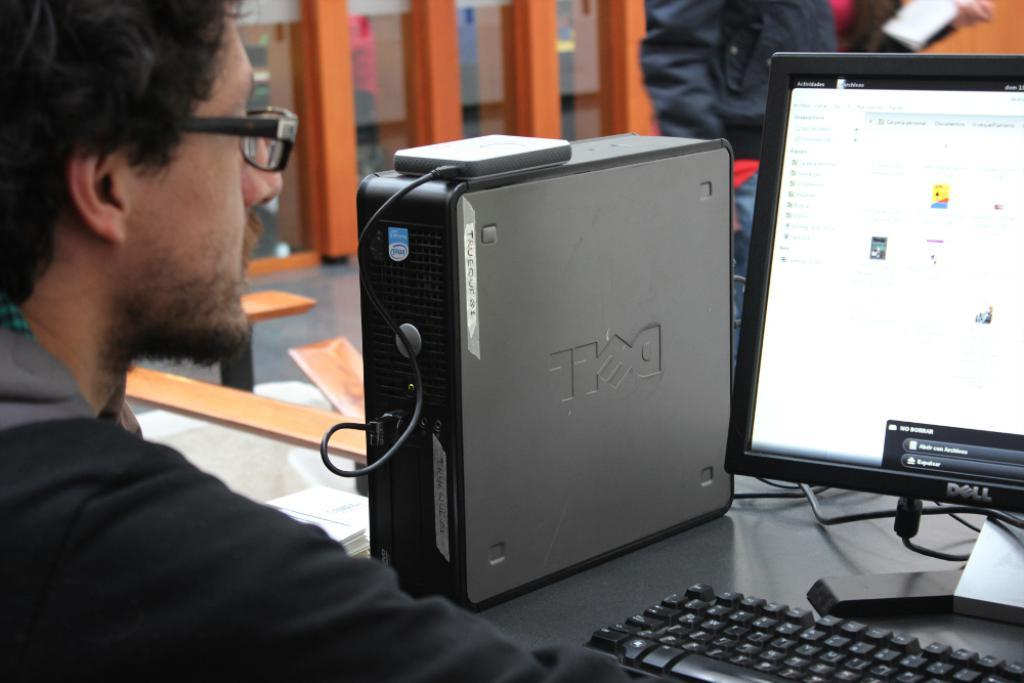<image>
Describe the image concisely. A man sitting in front of a desktop computer which has dell printed on it, upside down. 